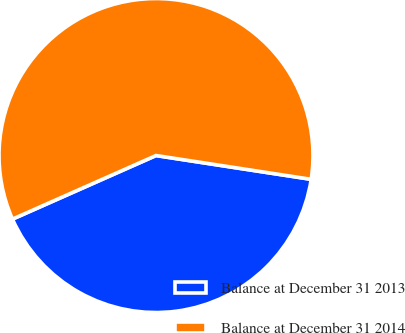Convert chart to OTSL. <chart><loc_0><loc_0><loc_500><loc_500><pie_chart><fcel>Balance at December 31 2013<fcel>Balance at December 31 2014<nl><fcel>40.94%<fcel>59.06%<nl></chart> 